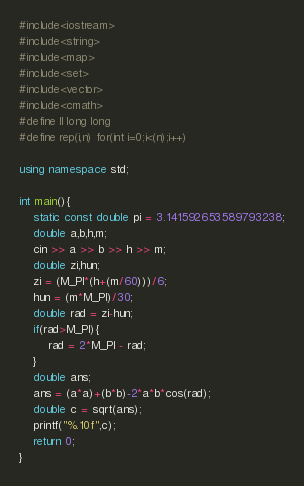<code> <loc_0><loc_0><loc_500><loc_500><_C++_>#include<iostream>
#include<string>
#include<map>
#include<set>
#include<vector>
#include<cmath>
#define ll long long
#define rep(i,n) for(int i=0;i<(n);i++)

using namespace std;

int main(){
    static const double pi = 3.141592653589793238;
    double a,b,h,m;
    cin >> a >> b >> h >> m;
    double zi,hun;
    zi = (M_PI*(h+(m/60)))/6;
    hun = (m*M_PI)/30;
    double rad = zi-hun;
    if(rad>M_PI){
        rad = 2*M_PI - rad; 
    }
    double ans;
    ans = (a*a)+(b*b)-2*a*b*cos(rad);
    double c = sqrt(ans);
    printf("%.10f",c);
    return 0;
}</code> 